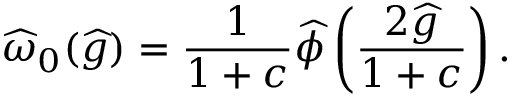<formula> <loc_0><loc_0><loc_500><loc_500>\widehat { \omega } _ { 0 } ( \widehat { g } ) = \frac { 1 } { 1 + c } \widehat { \phi } \left ( \frac { 2 \widehat { g } } { 1 + c } \right ) .</formula> 